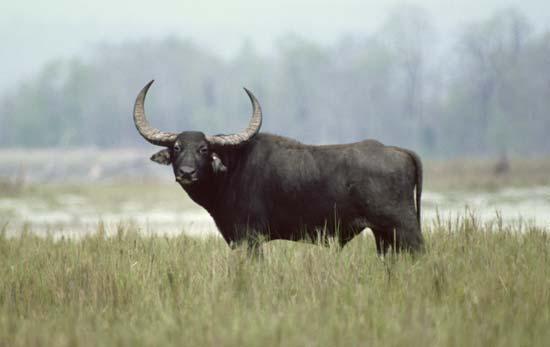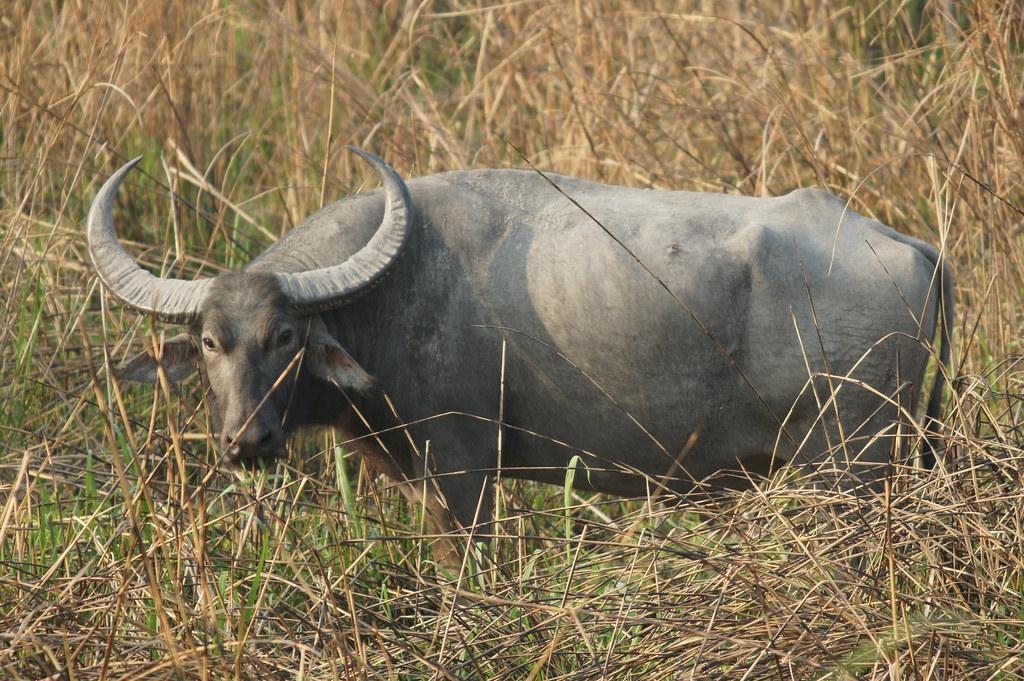The first image is the image on the left, the second image is the image on the right. Assess this claim about the two images: "Water bufallos are standing in water.". Correct or not? Answer yes or no. No. 